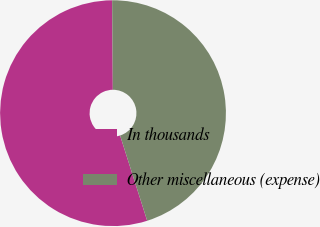Convert chart to OTSL. <chart><loc_0><loc_0><loc_500><loc_500><pie_chart><fcel>In thousands<fcel>Other miscellaneous (expense)<nl><fcel>54.77%<fcel>45.23%<nl></chart> 